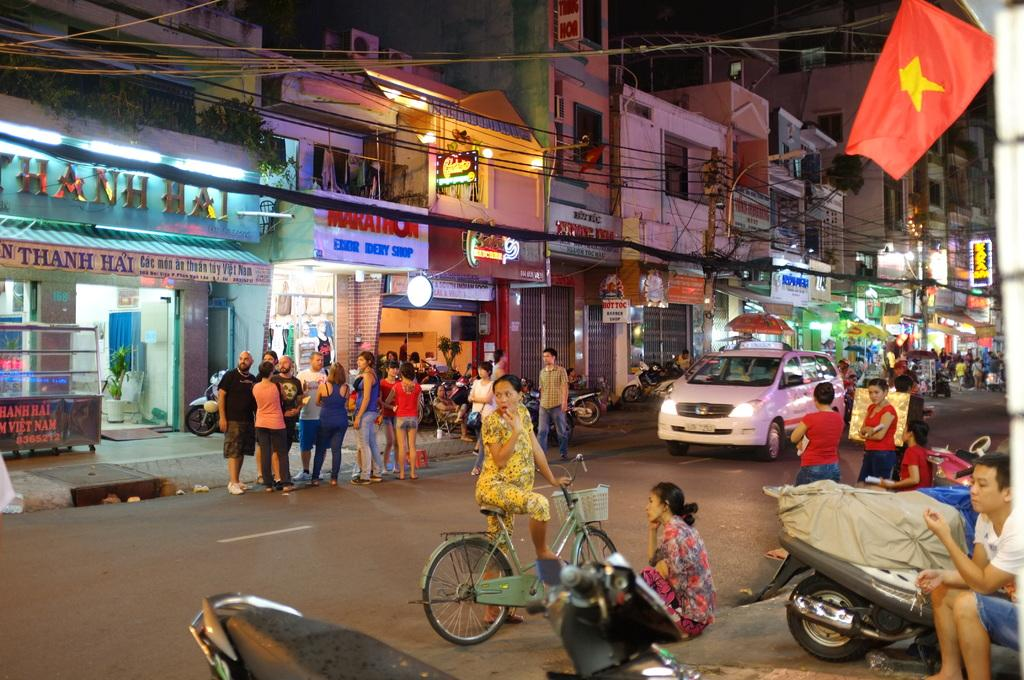<image>
Provide a brief description of the given image. A busy street has a group of people standing in front of a store that says Thanh Hai. 